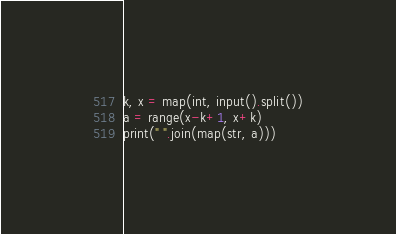Convert code to text. <code><loc_0><loc_0><loc_500><loc_500><_Python_>k, x = map(int, input().split())
a = range(x-k+1, x+k)
print(" ".join(map(str, a)))
</code> 